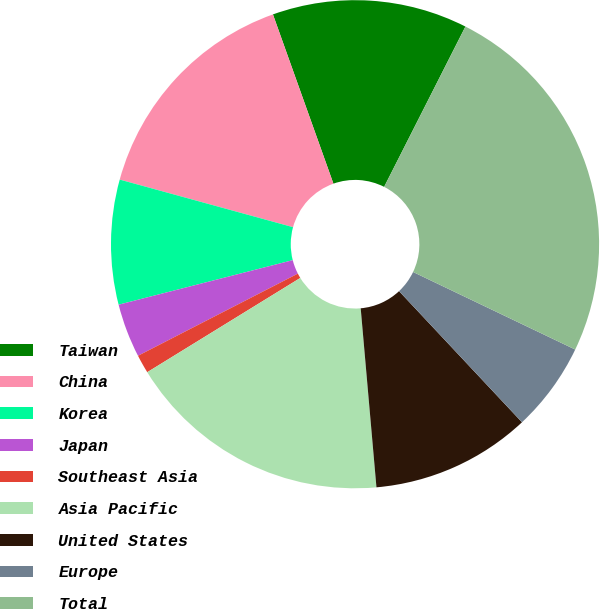<chart> <loc_0><loc_0><loc_500><loc_500><pie_chart><fcel>Taiwan<fcel>China<fcel>Korea<fcel>Japan<fcel>Southeast Asia<fcel>Asia Pacific<fcel>United States<fcel>Europe<fcel>Total<nl><fcel>12.93%<fcel>15.27%<fcel>8.25%<fcel>3.57%<fcel>1.23%<fcel>17.61%<fcel>10.59%<fcel>5.91%<fcel>24.63%<nl></chart> 